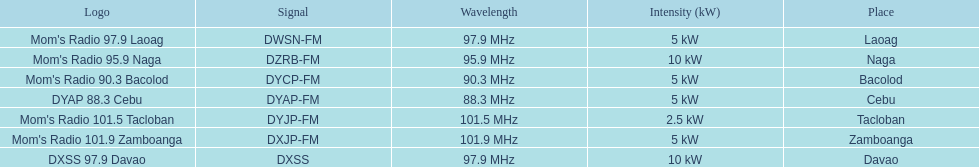How many stations have at least 5 kw or more listed in the power column? 6. 